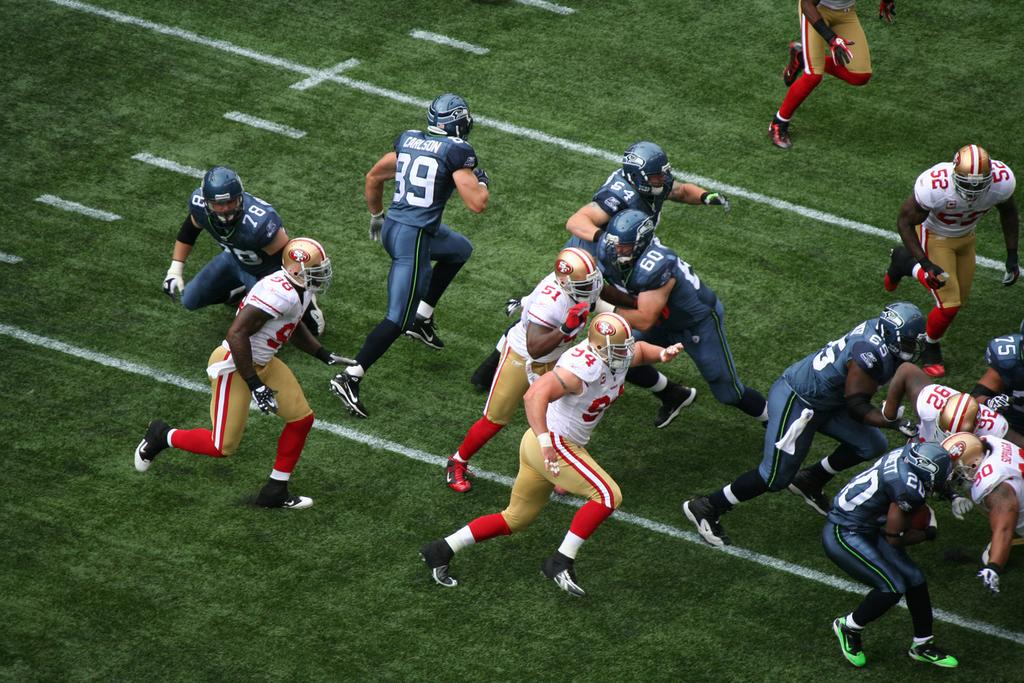Who or what is present in the image? There are people in the image. What activity are the people engaged in? The people are playing American football. What type of surface is visible at the bottom of the image? There is grass at the bottom of the image. How many noses can be seen on the football in the image? There are no noses present on the football in the image, as footballs do not have noses. 